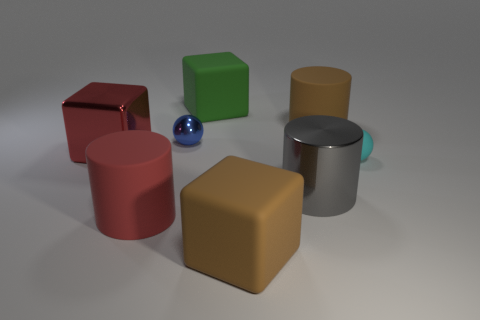Subtract all rubber cylinders. How many cylinders are left? 1 Subtract all blue spheres. How many spheres are left? 1 Add 2 large green rubber cubes. How many objects exist? 10 Subtract 1 cubes. How many cubes are left? 2 Add 6 large red cylinders. How many large red cylinders exist? 7 Subtract 0 purple cylinders. How many objects are left? 8 Subtract all blocks. How many objects are left? 5 Subtract all yellow cylinders. Subtract all brown balls. How many cylinders are left? 3 Subtract all gray spheres. How many cyan cylinders are left? 0 Subtract all cyan rubber spheres. Subtract all big things. How many objects are left? 1 